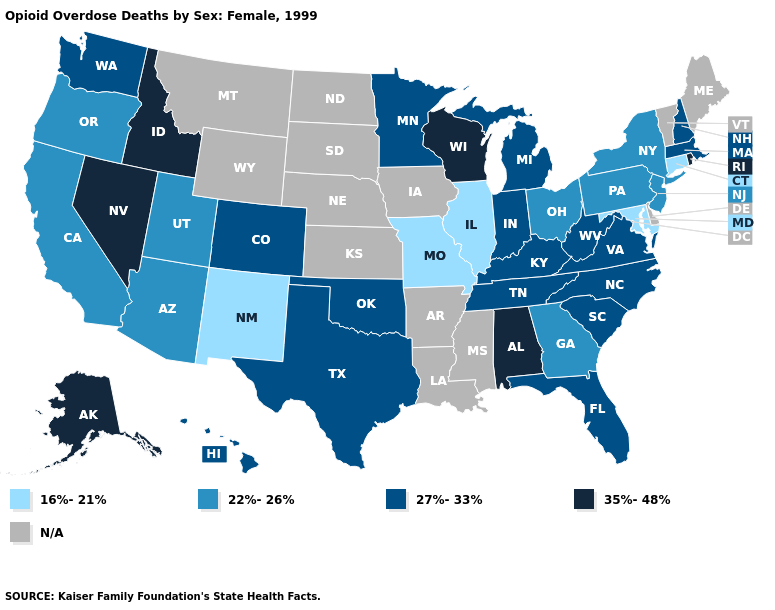Name the states that have a value in the range 35%-48%?
Short answer required. Alabama, Alaska, Idaho, Nevada, Rhode Island, Wisconsin. What is the lowest value in the USA?
Quick response, please. 16%-21%. Which states have the highest value in the USA?
Write a very short answer. Alabama, Alaska, Idaho, Nevada, Rhode Island, Wisconsin. What is the value of New Jersey?
Answer briefly. 22%-26%. Name the states that have a value in the range 35%-48%?
Keep it brief. Alabama, Alaska, Idaho, Nevada, Rhode Island, Wisconsin. What is the value of North Dakota?
Be succinct. N/A. Name the states that have a value in the range 22%-26%?
Quick response, please. Arizona, California, Georgia, New Jersey, New York, Ohio, Oregon, Pennsylvania, Utah. Which states have the lowest value in the MidWest?
Answer briefly. Illinois, Missouri. Name the states that have a value in the range 22%-26%?
Be succinct. Arizona, California, Georgia, New Jersey, New York, Ohio, Oregon, Pennsylvania, Utah. What is the highest value in states that border California?
Give a very brief answer. 35%-48%. What is the highest value in states that border Alabama?
Keep it brief. 27%-33%. Is the legend a continuous bar?
Short answer required. No. Does the map have missing data?
Be succinct. Yes. 